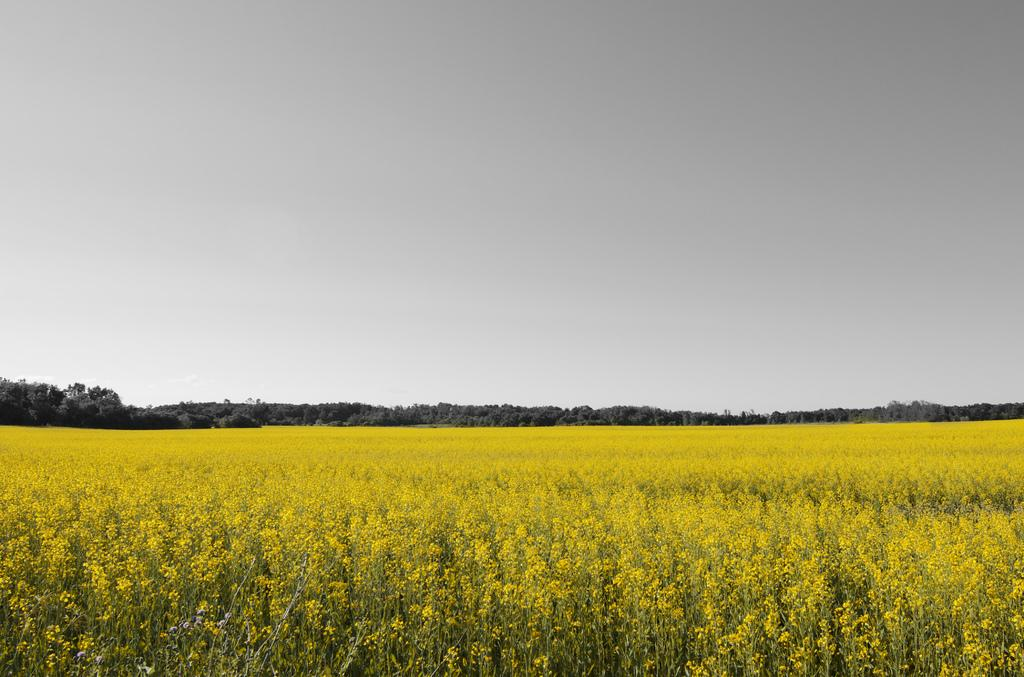What type of plants are at the bottom of the image? There are plants with flowers at the bottom of the image. What can be seen in the background of the image? There are trees and the sky visible in the background of the image. What type of jam is being spread on the trousers in the image? There are no trousers or jam present in the image. How many eggs are visible in the image? There are no eggs visible in the image. 